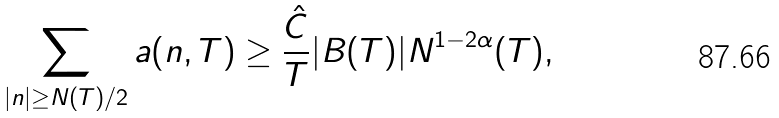Convert formula to latex. <formula><loc_0><loc_0><loc_500><loc_500>\sum _ { | n | \geq N ( T ) / 2 } a ( n , T ) \geq \frac { \hat { C } } { T } | B ( T ) | N ^ { 1 - 2 \alpha } ( T ) ,</formula> 